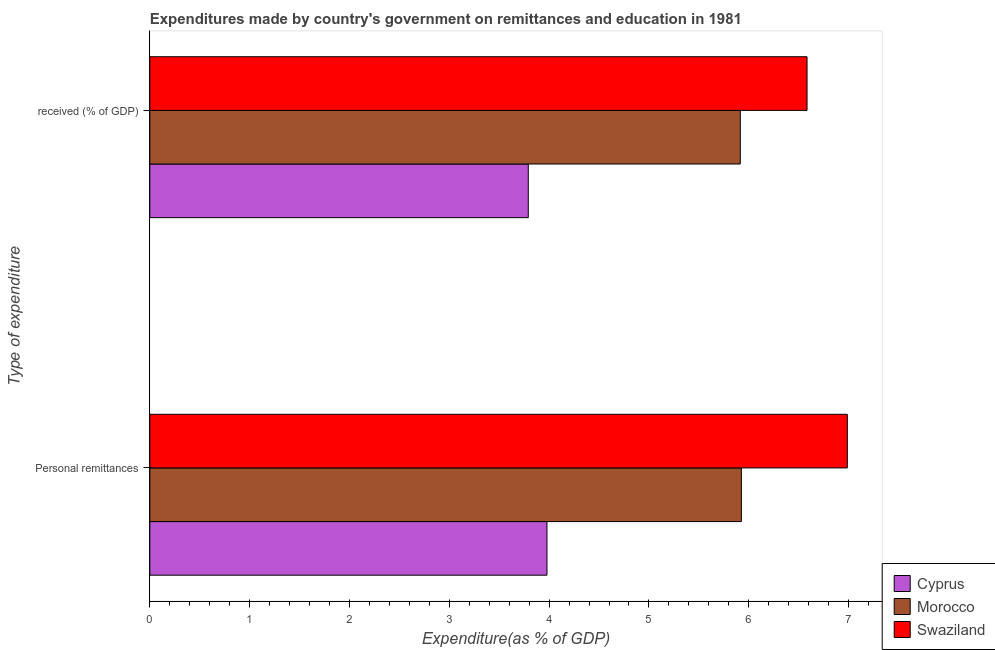How many groups of bars are there?
Your answer should be compact. 2. Are the number of bars on each tick of the Y-axis equal?
Offer a very short reply. Yes. How many bars are there on the 2nd tick from the bottom?
Offer a terse response. 3. What is the label of the 2nd group of bars from the top?
Keep it short and to the point. Personal remittances. What is the expenditure in personal remittances in Cyprus?
Provide a short and direct response. 3.98. Across all countries, what is the maximum expenditure in personal remittances?
Make the answer very short. 6.99. Across all countries, what is the minimum expenditure in personal remittances?
Make the answer very short. 3.98. In which country was the expenditure in personal remittances maximum?
Your answer should be very brief. Swaziland. In which country was the expenditure in personal remittances minimum?
Give a very brief answer. Cyprus. What is the total expenditure in education in the graph?
Ensure brevity in your answer.  16.29. What is the difference between the expenditure in personal remittances in Swaziland and that in Cyprus?
Your response must be concise. 3.01. What is the difference between the expenditure in education in Cyprus and the expenditure in personal remittances in Swaziland?
Make the answer very short. -3.2. What is the average expenditure in personal remittances per country?
Offer a terse response. 5.63. What is the difference between the expenditure in personal remittances and expenditure in education in Morocco?
Offer a very short reply. 0.01. What is the ratio of the expenditure in personal remittances in Cyprus to that in Swaziland?
Make the answer very short. 0.57. Is the expenditure in personal remittances in Morocco less than that in Cyprus?
Give a very brief answer. No. What does the 2nd bar from the top in Personal remittances represents?
Keep it short and to the point. Morocco. What does the 3rd bar from the bottom in  received (% of GDP) represents?
Give a very brief answer. Swaziland. How many countries are there in the graph?
Your response must be concise. 3. Are the values on the major ticks of X-axis written in scientific E-notation?
Provide a short and direct response. No. Does the graph contain any zero values?
Provide a succinct answer. No. Does the graph contain grids?
Give a very brief answer. No. Where does the legend appear in the graph?
Your answer should be compact. Bottom right. How are the legend labels stacked?
Make the answer very short. Vertical. What is the title of the graph?
Your answer should be compact. Expenditures made by country's government on remittances and education in 1981. What is the label or title of the X-axis?
Ensure brevity in your answer.  Expenditure(as % of GDP). What is the label or title of the Y-axis?
Make the answer very short. Type of expenditure. What is the Expenditure(as % of GDP) in Cyprus in Personal remittances?
Offer a very short reply. 3.98. What is the Expenditure(as % of GDP) of Morocco in Personal remittances?
Your answer should be very brief. 5.93. What is the Expenditure(as % of GDP) in Swaziland in Personal remittances?
Offer a terse response. 6.99. What is the Expenditure(as % of GDP) of Cyprus in  received (% of GDP)?
Make the answer very short. 3.79. What is the Expenditure(as % of GDP) in Morocco in  received (% of GDP)?
Provide a short and direct response. 5.92. What is the Expenditure(as % of GDP) of Swaziland in  received (% of GDP)?
Make the answer very short. 6.58. Across all Type of expenditure, what is the maximum Expenditure(as % of GDP) of Cyprus?
Ensure brevity in your answer.  3.98. Across all Type of expenditure, what is the maximum Expenditure(as % of GDP) in Morocco?
Offer a very short reply. 5.93. Across all Type of expenditure, what is the maximum Expenditure(as % of GDP) of Swaziland?
Ensure brevity in your answer.  6.99. Across all Type of expenditure, what is the minimum Expenditure(as % of GDP) of Cyprus?
Keep it short and to the point. 3.79. Across all Type of expenditure, what is the minimum Expenditure(as % of GDP) in Morocco?
Your response must be concise. 5.92. Across all Type of expenditure, what is the minimum Expenditure(as % of GDP) in Swaziland?
Your answer should be compact. 6.58. What is the total Expenditure(as % of GDP) of Cyprus in the graph?
Your answer should be compact. 7.77. What is the total Expenditure(as % of GDP) in Morocco in the graph?
Give a very brief answer. 11.84. What is the total Expenditure(as % of GDP) of Swaziland in the graph?
Ensure brevity in your answer.  13.57. What is the difference between the Expenditure(as % of GDP) of Cyprus in Personal remittances and that in  received (% of GDP)?
Keep it short and to the point. 0.19. What is the difference between the Expenditure(as % of GDP) in Morocco in Personal remittances and that in  received (% of GDP)?
Make the answer very short. 0.01. What is the difference between the Expenditure(as % of GDP) in Swaziland in Personal remittances and that in  received (% of GDP)?
Give a very brief answer. 0.4. What is the difference between the Expenditure(as % of GDP) in Cyprus in Personal remittances and the Expenditure(as % of GDP) in Morocco in  received (% of GDP)?
Provide a short and direct response. -1.94. What is the difference between the Expenditure(as % of GDP) in Cyprus in Personal remittances and the Expenditure(as % of GDP) in Swaziland in  received (% of GDP)?
Your answer should be very brief. -2.61. What is the difference between the Expenditure(as % of GDP) in Morocco in Personal remittances and the Expenditure(as % of GDP) in Swaziland in  received (% of GDP)?
Your answer should be very brief. -0.66. What is the average Expenditure(as % of GDP) of Cyprus per Type of expenditure?
Ensure brevity in your answer.  3.88. What is the average Expenditure(as % of GDP) in Morocco per Type of expenditure?
Provide a succinct answer. 5.92. What is the average Expenditure(as % of GDP) of Swaziland per Type of expenditure?
Offer a very short reply. 6.79. What is the difference between the Expenditure(as % of GDP) in Cyprus and Expenditure(as % of GDP) in Morocco in Personal remittances?
Give a very brief answer. -1.95. What is the difference between the Expenditure(as % of GDP) in Cyprus and Expenditure(as % of GDP) in Swaziland in Personal remittances?
Provide a short and direct response. -3.01. What is the difference between the Expenditure(as % of GDP) in Morocco and Expenditure(as % of GDP) in Swaziland in Personal remittances?
Provide a short and direct response. -1.06. What is the difference between the Expenditure(as % of GDP) in Cyprus and Expenditure(as % of GDP) in Morocco in  received (% of GDP)?
Offer a very short reply. -2.12. What is the difference between the Expenditure(as % of GDP) in Cyprus and Expenditure(as % of GDP) in Swaziland in  received (% of GDP)?
Make the answer very short. -2.79. What is the difference between the Expenditure(as % of GDP) of Morocco and Expenditure(as % of GDP) of Swaziland in  received (% of GDP)?
Offer a very short reply. -0.67. What is the ratio of the Expenditure(as % of GDP) of Cyprus in Personal remittances to that in  received (% of GDP)?
Your answer should be very brief. 1.05. What is the ratio of the Expenditure(as % of GDP) of Morocco in Personal remittances to that in  received (% of GDP)?
Give a very brief answer. 1. What is the ratio of the Expenditure(as % of GDP) of Swaziland in Personal remittances to that in  received (% of GDP)?
Provide a succinct answer. 1.06. What is the difference between the highest and the second highest Expenditure(as % of GDP) of Cyprus?
Your answer should be very brief. 0.19. What is the difference between the highest and the second highest Expenditure(as % of GDP) of Morocco?
Make the answer very short. 0.01. What is the difference between the highest and the second highest Expenditure(as % of GDP) in Swaziland?
Your answer should be compact. 0.4. What is the difference between the highest and the lowest Expenditure(as % of GDP) in Cyprus?
Your response must be concise. 0.19. What is the difference between the highest and the lowest Expenditure(as % of GDP) in Morocco?
Give a very brief answer. 0.01. What is the difference between the highest and the lowest Expenditure(as % of GDP) in Swaziland?
Ensure brevity in your answer.  0.4. 